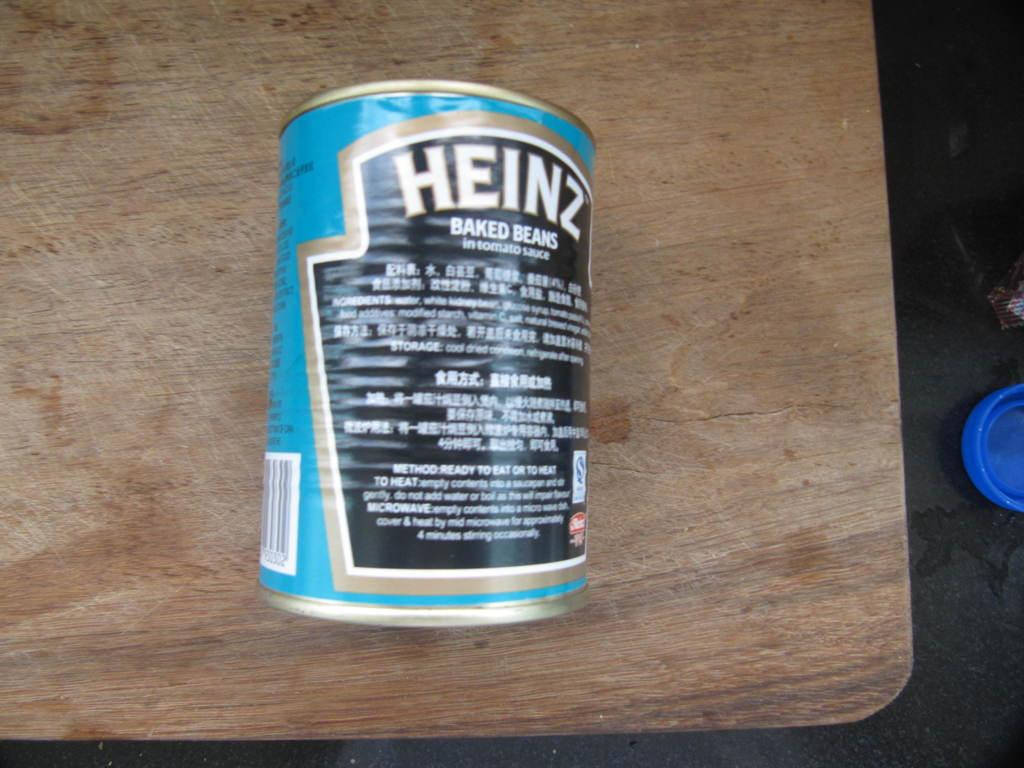<image>
Write a terse but informative summary of the picture. A can of Heinz baked beans on a table. 